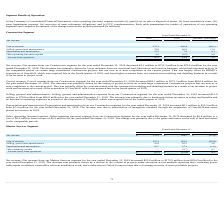According to Hc2 Holdings's financial document, What was the net revenue from Marine Services segment for the year ended December 31, 2019? According to the financial document, $172.5 million. The relevant text states: "ended December 31, 2019 decreased $21.8 million to $172.5 million from $194.3 million for the year ended December 31, 2018. The decrease was primarily driven by a dec..." Also, What was the net revenue from Marine Services segment for the year ended December 31, 2018? According to the financial document, $194.3 million. The relevant text states: "019 decreased $21.8 million to $172.5 million from $194.3 million for the year ended December 31, 2018. The decrease was primarily driven by a decline in the volume o..." Also, What was the cost of revenue from Marine Services segment for the year ended December 31, 2019? Based on the financial document, the answer is $127.1 million. Also, can you calculate: What was the percentage change in the net revenue from 2018 to 2019? To answer this question, I need to perform calculations using the financial data. The calculation is: 172.5 / 194.3 - 1, which equals -11.22 (percentage). This is based on the information: "Net revenue $ 172.5 $ 194.3 $ (21.8) Net revenue $ 172.5 $ 194.3 $ (21.8)..." The key data points involved are: 172.5, 194.3. Also, can you calculate: What was the average cost of revenue for 2018 and 2019? To answer this question, I need to perform calculations using the financial data. The calculation is: (127.1 + 163.0) / 2, which equals 145.05 (in millions). This is based on the information: "Cost of revenue 127.1 163.0 (35.9) Cost of revenue 127.1 163.0 (35.9)..." The key data points involved are: 127.1, 163.0. Also, can you calculate: What is the percentage change in the Depreciation and amortization from 2018 to 2019? To answer this question, I need to perform calculations using the financial data. The calculation is: 25.7 / 27.2 - 1, which equals -5.51 (percentage). This is based on the information: "Depreciation and amortization 25.7 27.2 (1.5) Depreciation and amortization 25.7 27.2 (1.5)..." The key data points involved are: 25.7, 27.2. 